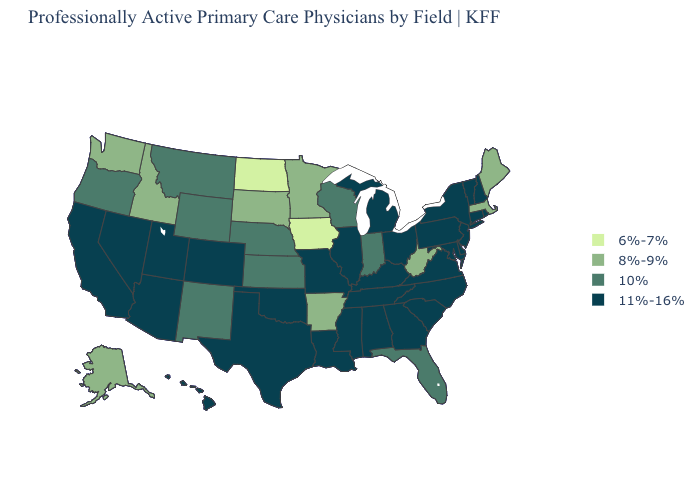Which states have the highest value in the USA?
Write a very short answer. Alabama, Arizona, California, Colorado, Connecticut, Delaware, Georgia, Hawaii, Illinois, Kentucky, Louisiana, Maryland, Michigan, Mississippi, Missouri, Nevada, New Hampshire, New Jersey, New York, North Carolina, Ohio, Oklahoma, Pennsylvania, Rhode Island, South Carolina, Tennessee, Texas, Utah, Vermont, Virginia. Does North Dakota have the lowest value in the USA?
Write a very short answer. Yes. Among the states that border Vermont , which have the highest value?
Concise answer only. New Hampshire, New York. Name the states that have a value in the range 10%?
Concise answer only. Florida, Indiana, Kansas, Montana, Nebraska, New Mexico, Oregon, Wisconsin, Wyoming. What is the value of South Dakota?
Quick response, please. 8%-9%. Name the states that have a value in the range 6%-7%?
Give a very brief answer. Iowa, North Dakota. Which states have the lowest value in the Northeast?
Be succinct. Maine, Massachusetts. What is the value of South Carolina?
Give a very brief answer. 11%-16%. Among the states that border Alabama , which have the lowest value?
Keep it brief. Florida. What is the value of Washington?
Short answer required. 8%-9%. What is the value of Kentucky?
Write a very short answer. 11%-16%. What is the highest value in the USA?
Answer briefly. 11%-16%. Does South Carolina have the same value as Michigan?
Quick response, please. Yes. What is the lowest value in states that border Alabama?
Short answer required. 10%. 